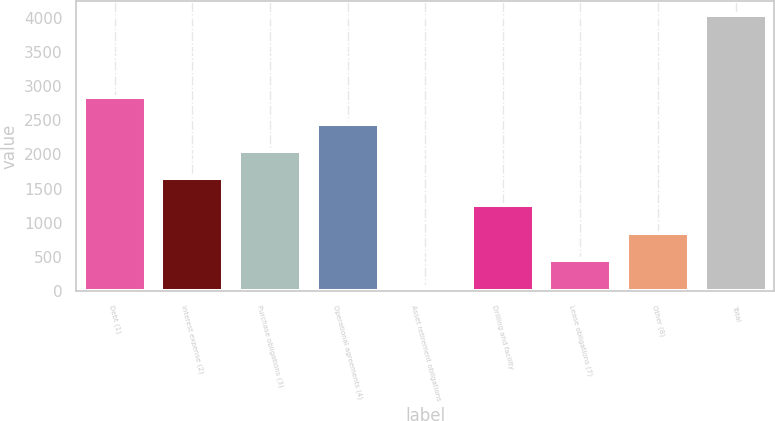Convert chart. <chart><loc_0><loc_0><loc_500><loc_500><bar_chart><fcel>Debt (1)<fcel>Interest expense (2)<fcel>Purchase obligations (3)<fcel>Operational agreements (4)<fcel>Asset retirement obligations<fcel>Drilling and facility<fcel>Lease obligations (7)<fcel>Other (8)<fcel>Total<nl><fcel>2843.9<fcel>1650.8<fcel>2048.5<fcel>2446.2<fcel>60<fcel>1253.1<fcel>457.7<fcel>855.4<fcel>4037<nl></chart> 